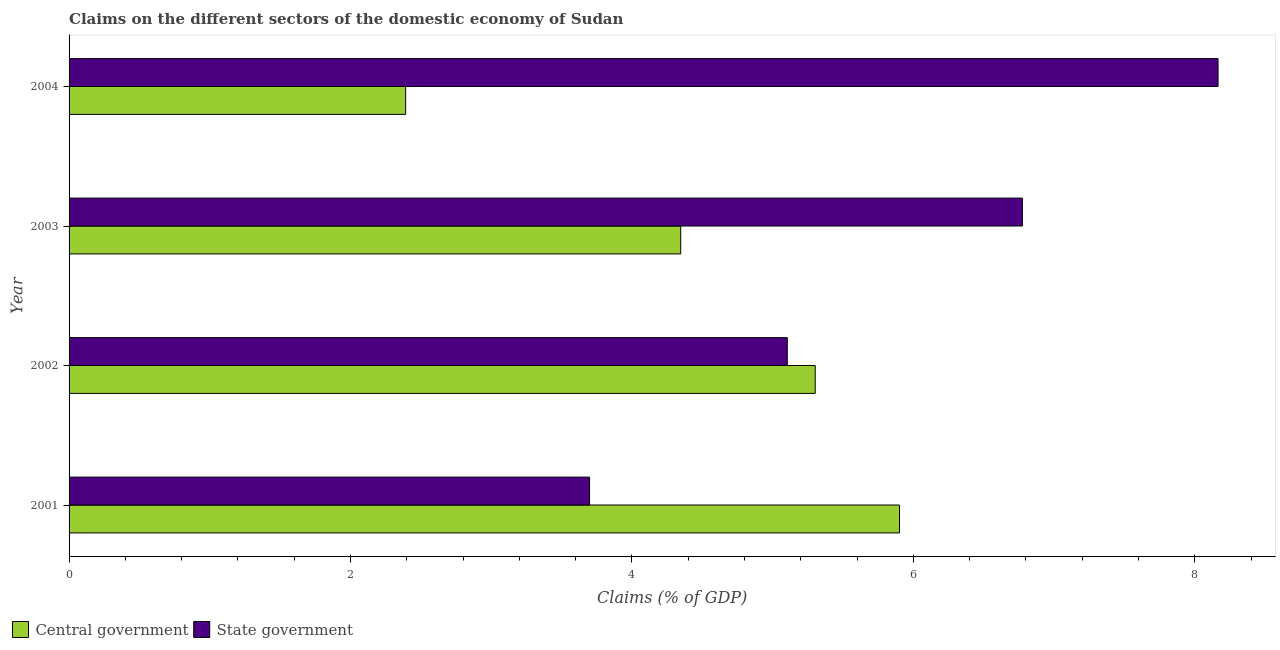How many groups of bars are there?
Make the answer very short. 4. Are the number of bars per tick equal to the number of legend labels?
Your response must be concise. Yes. Are the number of bars on each tick of the Y-axis equal?
Ensure brevity in your answer.  Yes. In how many cases, is the number of bars for a given year not equal to the number of legend labels?
Your answer should be compact. 0. What is the claims on state government in 2003?
Your answer should be very brief. 6.77. Across all years, what is the maximum claims on central government?
Offer a terse response. 5.9. Across all years, what is the minimum claims on central government?
Provide a short and direct response. 2.39. In which year was the claims on state government maximum?
Your response must be concise. 2004. What is the total claims on state government in the graph?
Your answer should be very brief. 23.74. What is the difference between the claims on state government in 2001 and that in 2003?
Your answer should be very brief. -3.08. What is the difference between the claims on central government in 2002 and the claims on state government in 2001?
Your response must be concise. 1.6. What is the average claims on central government per year?
Ensure brevity in your answer.  4.49. In the year 2002, what is the difference between the claims on state government and claims on central government?
Provide a short and direct response. -0.2. In how many years, is the claims on state government greater than 1.6 %?
Provide a short and direct response. 4. What is the ratio of the claims on central government in 2002 to that in 2004?
Make the answer very short. 2.22. Is the difference between the claims on central government in 2001 and 2002 greater than the difference between the claims on state government in 2001 and 2002?
Give a very brief answer. Yes. What is the difference between the highest and the second highest claims on central government?
Ensure brevity in your answer.  0.6. What is the difference between the highest and the lowest claims on state government?
Your answer should be very brief. 4.47. In how many years, is the claims on state government greater than the average claims on state government taken over all years?
Give a very brief answer. 2. What does the 2nd bar from the top in 2004 represents?
Keep it short and to the point. Central government. What does the 1st bar from the bottom in 2001 represents?
Offer a terse response. Central government. How many bars are there?
Your answer should be very brief. 8. Are all the bars in the graph horizontal?
Ensure brevity in your answer.  Yes. Are the values on the major ticks of X-axis written in scientific E-notation?
Your response must be concise. No. Where does the legend appear in the graph?
Offer a very short reply. Bottom left. How are the legend labels stacked?
Ensure brevity in your answer.  Horizontal. What is the title of the graph?
Provide a short and direct response. Claims on the different sectors of the domestic economy of Sudan. What is the label or title of the X-axis?
Offer a very short reply. Claims (% of GDP). What is the Claims (% of GDP) of Central government in 2001?
Your response must be concise. 5.9. What is the Claims (% of GDP) of State government in 2001?
Your answer should be compact. 3.7. What is the Claims (% of GDP) in Central government in 2002?
Give a very brief answer. 5.3. What is the Claims (% of GDP) of State government in 2002?
Keep it short and to the point. 5.1. What is the Claims (% of GDP) in Central government in 2003?
Ensure brevity in your answer.  4.35. What is the Claims (% of GDP) of State government in 2003?
Provide a short and direct response. 6.77. What is the Claims (% of GDP) in Central government in 2004?
Offer a terse response. 2.39. What is the Claims (% of GDP) of State government in 2004?
Provide a short and direct response. 8.17. Across all years, what is the maximum Claims (% of GDP) in Central government?
Offer a terse response. 5.9. Across all years, what is the maximum Claims (% of GDP) in State government?
Keep it short and to the point. 8.17. Across all years, what is the minimum Claims (% of GDP) of Central government?
Give a very brief answer. 2.39. Across all years, what is the minimum Claims (% of GDP) of State government?
Provide a short and direct response. 3.7. What is the total Claims (% of GDP) of Central government in the graph?
Offer a terse response. 17.94. What is the total Claims (% of GDP) in State government in the graph?
Provide a short and direct response. 23.74. What is the difference between the Claims (% of GDP) in Central government in 2001 and that in 2002?
Provide a succinct answer. 0.6. What is the difference between the Claims (% of GDP) of State government in 2001 and that in 2002?
Provide a short and direct response. -1.41. What is the difference between the Claims (% of GDP) of Central government in 2001 and that in 2003?
Offer a terse response. 1.55. What is the difference between the Claims (% of GDP) of State government in 2001 and that in 2003?
Give a very brief answer. -3.08. What is the difference between the Claims (% of GDP) of Central government in 2001 and that in 2004?
Your answer should be compact. 3.51. What is the difference between the Claims (% of GDP) in State government in 2001 and that in 2004?
Offer a terse response. -4.47. What is the difference between the Claims (% of GDP) of Central government in 2002 and that in 2003?
Offer a terse response. 0.96. What is the difference between the Claims (% of GDP) in State government in 2002 and that in 2003?
Keep it short and to the point. -1.67. What is the difference between the Claims (% of GDP) of Central government in 2002 and that in 2004?
Ensure brevity in your answer.  2.91. What is the difference between the Claims (% of GDP) in State government in 2002 and that in 2004?
Ensure brevity in your answer.  -3.06. What is the difference between the Claims (% of GDP) in Central government in 2003 and that in 2004?
Your answer should be compact. 1.95. What is the difference between the Claims (% of GDP) in State government in 2003 and that in 2004?
Ensure brevity in your answer.  -1.39. What is the difference between the Claims (% of GDP) of Central government in 2001 and the Claims (% of GDP) of State government in 2002?
Provide a short and direct response. 0.8. What is the difference between the Claims (% of GDP) in Central government in 2001 and the Claims (% of GDP) in State government in 2003?
Provide a succinct answer. -0.87. What is the difference between the Claims (% of GDP) of Central government in 2001 and the Claims (% of GDP) of State government in 2004?
Provide a short and direct response. -2.26. What is the difference between the Claims (% of GDP) in Central government in 2002 and the Claims (% of GDP) in State government in 2003?
Your answer should be very brief. -1.47. What is the difference between the Claims (% of GDP) of Central government in 2002 and the Claims (% of GDP) of State government in 2004?
Offer a terse response. -2.86. What is the difference between the Claims (% of GDP) in Central government in 2003 and the Claims (% of GDP) in State government in 2004?
Make the answer very short. -3.82. What is the average Claims (% of GDP) of Central government per year?
Make the answer very short. 4.49. What is the average Claims (% of GDP) in State government per year?
Offer a terse response. 5.94. In the year 2001, what is the difference between the Claims (% of GDP) of Central government and Claims (% of GDP) of State government?
Your answer should be very brief. 2.2. In the year 2002, what is the difference between the Claims (% of GDP) of Central government and Claims (% of GDP) of State government?
Provide a short and direct response. 0.2. In the year 2003, what is the difference between the Claims (% of GDP) of Central government and Claims (% of GDP) of State government?
Ensure brevity in your answer.  -2.43. In the year 2004, what is the difference between the Claims (% of GDP) of Central government and Claims (% of GDP) of State government?
Your response must be concise. -5.77. What is the ratio of the Claims (% of GDP) in Central government in 2001 to that in 2002?
Provide a short and direct response. 1.11. What is the ratio of the Claims (% of GDP) in State government in 2001 to that in 2002?
Provide a short and direct response. 0.72. What is the ratio of the Claims (% of GDP) in Central government in 2001 to that in 2003?
Offer a very short reply. 1.36. What is the ratio of the Claims (% of GDP) of State government in 2001 to that in 2003?
Offer a terse response. 0.55. What is the ratio of the Claims (% of GDP) of Central government in 2001 to that in 2004?
Provide a succinct answer. 2.47. What is the ratio of the Claims (% of GDP) in State government in 2001 to that in 2004?
Your response must be concise. 0.45. What is the ratio of the Claims (% of GDP) of Central government in 2002 to that in 2003?
Your response must be concise. 1.22. What is the ratio of the Claims (% of GDP) in State government in 2002 to that in 2003?
Give a very brief answer. 0.75. What is the ratio of the Claims (% of GDP) in Central government in 2002 to that in 2004?
Your answer should be compact. 2.22. What is the ratio of the Claims (% of GDP) of State government in 2002 to that in 2004?
Keep it short and to the point. 0.63. What is the ratio of the Claims (% of GDP) of Central government in 2003 to that in 2004?
Offer a very short reply. 1.82. What is the ratio of the Claims (% of GDP) in State government in 2003 to that in 2004?
Keep it short and to the point. 0.83. What is the difference between the highest and the second highest Claims (% of GDP) of Central government?
Offer a very short reply. 0.6. What is the difference between the highest and the second highest Claims (% of GDP) of State government?
Ensure brevity in your answer.  1.39. What is the difference between the highest and the lowest Claims (% of GDP) in Central government?
Provide a short and direct response. 3.51. What is the difference between the highest and the lowest Claims (% of GDP) in State government?
Offer a terse response. 4.47. 